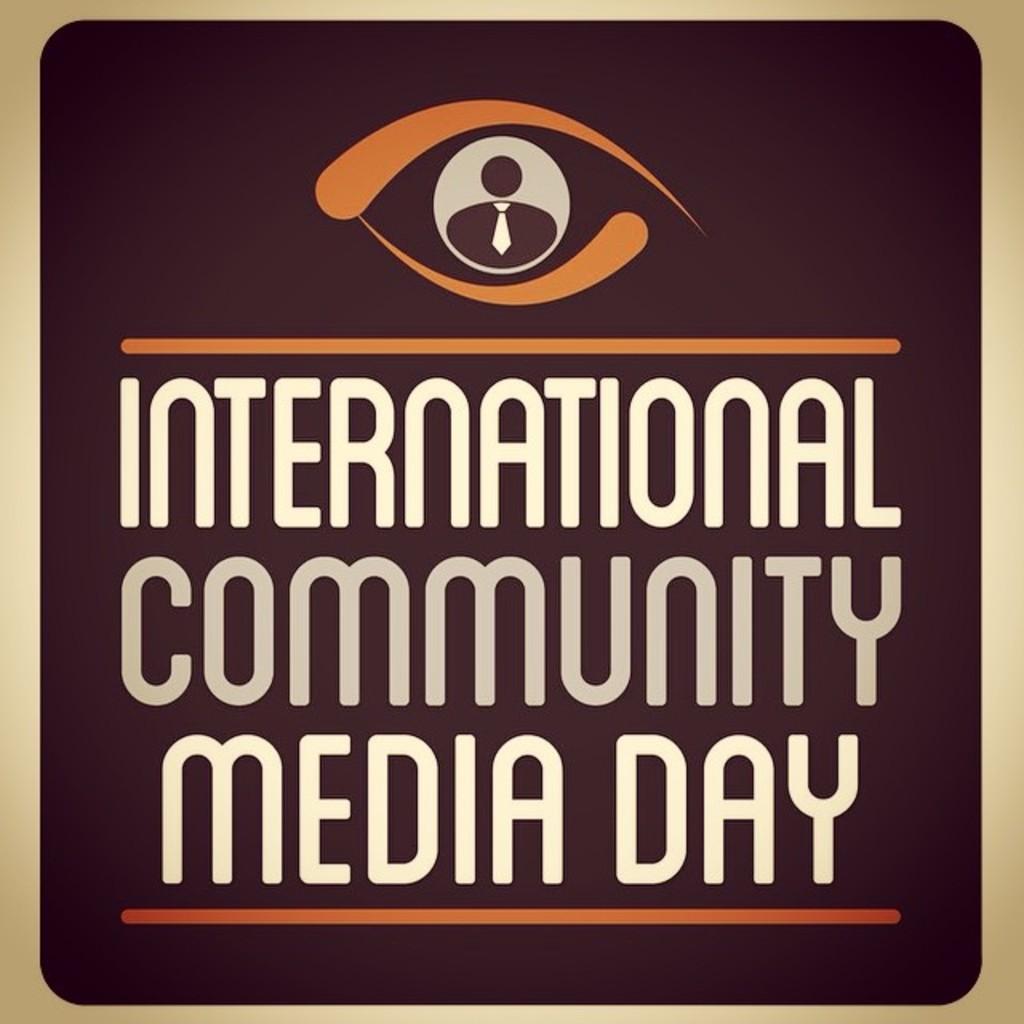What day is it according to the sign?
Make the answer very short. International community media day. What kind of day?
Provide a short and direct response. International community media day. 